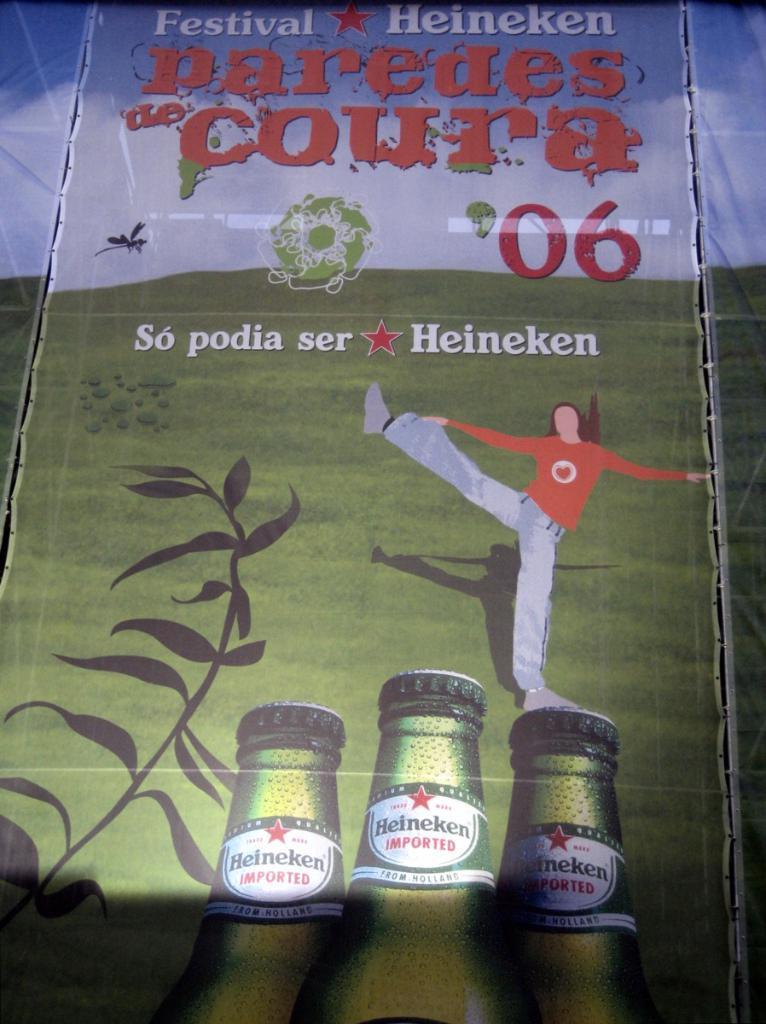Could you give a brief overview of what you see in this image? In this image we can see banners. On the banner we can see the picture of a cartoon person, wine bottles, plant, grass on the ground, texts and clouds in the sky. 